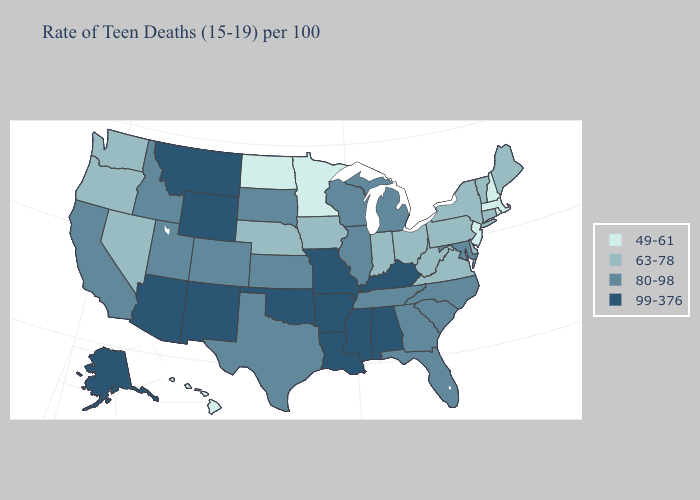Does Missouri have the highest value in the MidWest?
Give a very brief answer. Yes. Among the states that border Kentucky , does Tennessee have the highest value?
Answer briefly. No. Does New Jersey have the lowest value in the USA?
Short answer required. Yes. What is the highest value in the West ?
Short answer required. 99-376. Name the states that have a value in the range 49-61?
Answer briefly. Hawaii, Massachusetts, Minnesota, New Hampshire, New Jersey, North Dakota, Rhode Island. What is the value of Montana?
Be succinct. 99-376. What is the lowest value in the USA?
Short answer required. 49-61. Which states have the highest value in the USA?
Give a very brief answer. Alabama, Alaska, Arizona, Arkansas, Kentucky, Louisiana, Mississippi, Missouri, Montana, New Mexico, Oklahoma, Wyoming. Name the states that have a value in the range 49-61?
Write a very short answer. Hawaii, Massachusetts, Minnesota, New Hampshire, New Jersey, North Dakota, Rhode Island. Does Pennsylvania have the lowest value in the Northeast?
Short answer required. No. Does Hawaii have a higher value than Massachusetts?
Write a very short answer. No. Does New Mexico have the lowest value in the USA?
Quick response, please. No. Which states have the lowest value in the South?
Write a very short answer. Delaware, Virginia, West Virginia. Among the states that border North Carolina , which have the highest value?
Write a very short answer. Georgia, South Carolina, Tennessee. What is the lowest value in the MidWest?
Keep it brief. 49-61. 